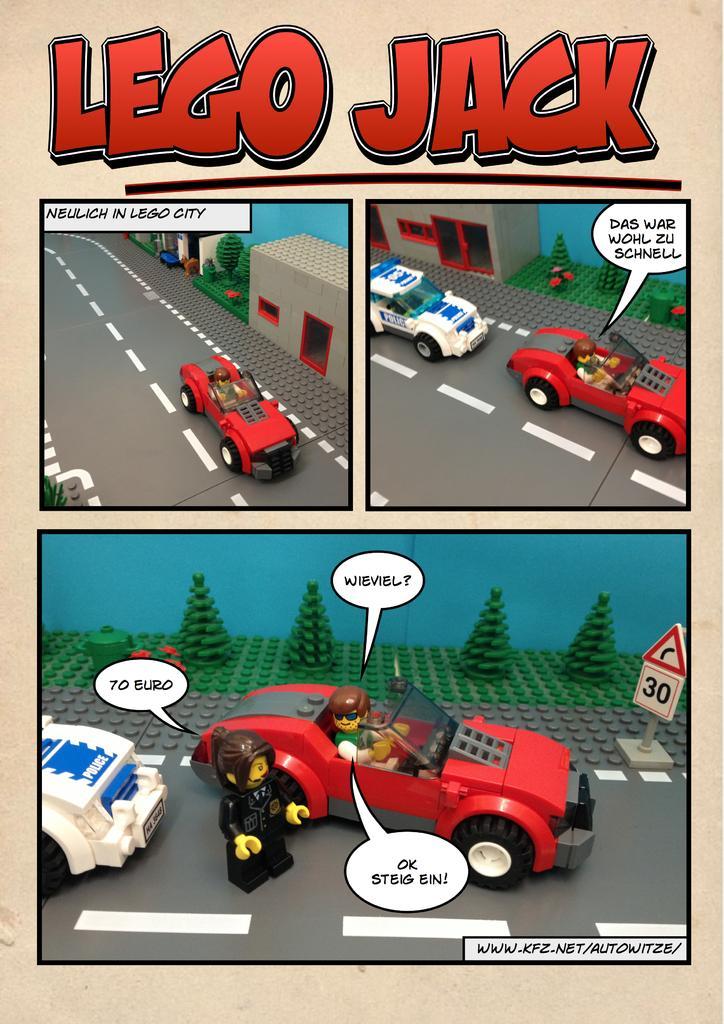Please provide a concise description of this image. In this image we can see a poster with some cartoon pictures, and text on it. 